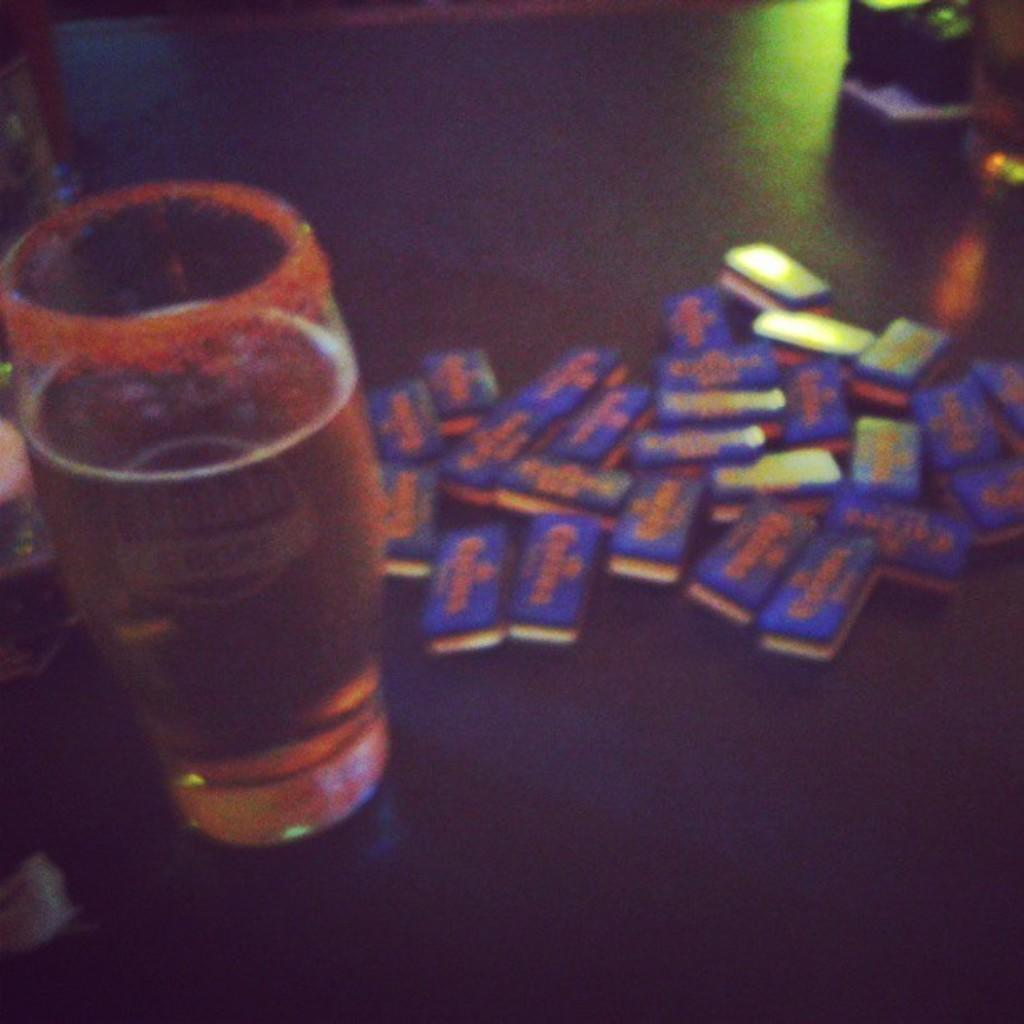What is located on the left side of the image? There is a beer glass on the left side of the image. What is on the opposite side of the image? There are chocolates on the right side of the image. How many people are in the crowd surrounding the heart-shaped goat in the image? There is no crowd, heart, or goat present in the image. 